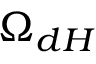Convert formula to latex. <formula><loc_0><loc_0><loc_500><loc_500>\Omega _ { d H }</formula> 